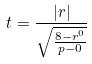Convert formula to latex. <formula><loc_0><loc_0><loc_500><loc_500>t = \frac { | r | } { \sqrt { \frac { 8 - r ^ { 0 } } { p - 0 } } }</formula> 